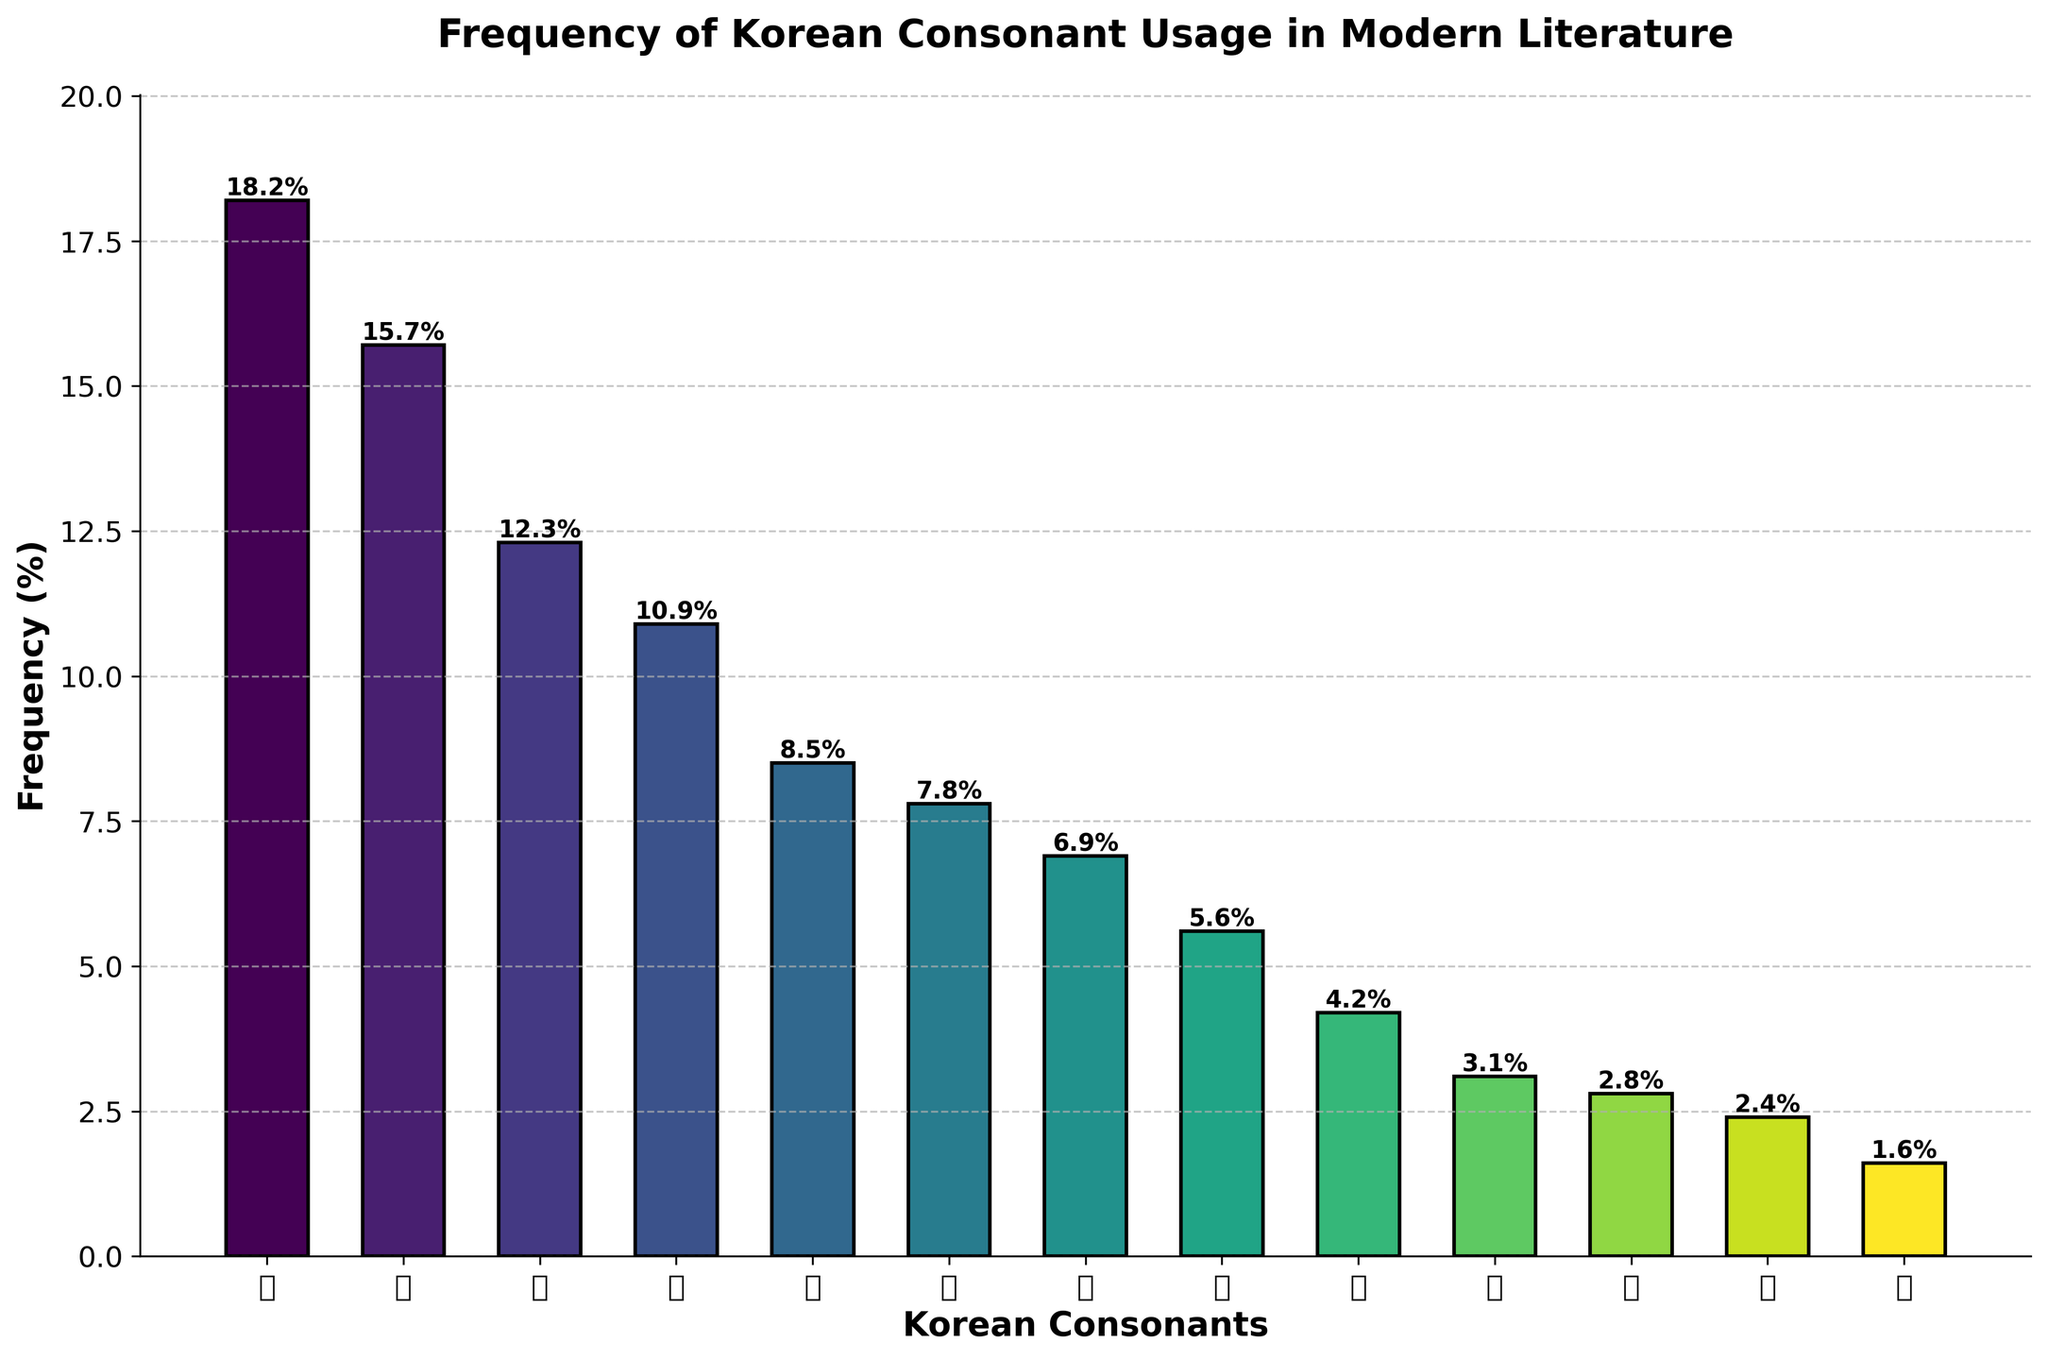What is the most frequently used Korean consonant in modern literature? The tallest bar in the chart represents the consonant with the highest frequency. The bar for ㄱ reaches the highest point, indicating it is the most frequently used consonant.
Answer: ㄱ Which consonant has the lowest frequency of usage? The shortest bar in the chart represents the consonant with the lowest frequency. The bar for ㅎ is the shortest, indicating it is the least frequently used consonant.
Answer: ㅎ What is the combined frequency of consonants ㄱ, ㄴ, and ㄷ? Add the frequencies of ㄱ (18.2), ㄴ (15.7), and ㄷ (12.3) together: 18.2 + 15.7 + 12.3 = 46.2.
Answer: 46.2% Which consonant has a slightly higher frequency, ㅂ or ㅅ? Compare the heights of the bars for ㅂ and ㅅ. The bar for ㅂ is slightly taller than the bar for ㅅ, indicating a higher frequency.
Answer: ㅂ What is the average frequency of the consonants that have more than 10% usage? Consonants with frequencies above 10% are ㄱ (18.2), ㄴ (15.7), ㄷ (12.3), and ㄹ (10.9). Their average frequency is calculated as (18.2 + 15.7 + 12.3 + 10.9) / 4 = 57.1 / 4 = 14.275.
Answer: 14.275% How does the usage frequency of ㅊ compare to that of ㅋ? Compare the heights of the bars for ㅊ and ㅋ. The bar for ㅊ is taller than the bar for ㅋ, indicating that ㅊ has a higher frequency of usage.
Answer: ㅊ Is the frequency of ㅎ usage less than half the frequency of ㄷ usage? Compare half the frequency of ㄷ (12.3 / 2 = 6.15) to the frequency of ㅎ (1.6). Since 1.6 < 6.15, the frequency of ㅎ is less than half of ㄷ.
Answer: Yes What is the cumulative frequency of the consonants ㄷ, ㅂ, ㅅ, ㅈ, and ㅎ? Add the frequencies of ㄷ (12.3), ㅂ (7.8), ㅅ (6.9), ㅈ (5.6), and ㅎ (1.6) together: 12.3 + 7.8 + 6.9 + 5.6 + 1.6 = 34.2.
Answer: 34.2% Which consonant has a frequency greater than 3% but less than 5%? Evaluate the frequencies of each consonant and find the bar that falls between 3% and 5%. The bar for ㅊ at 4.2% meets this criterion.
Answer: ㅊ 